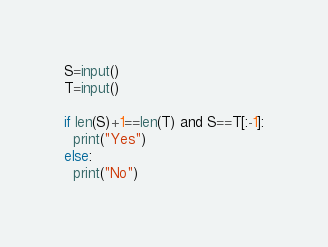Convert code to text. <code><loc_0><loc_0><loc_500><loc_500><_Python_>S=input()
T=input()

if len(S)+1==len(T) and S==T[:-1]:
  print("Yes")
else:
  print("No")</code> 